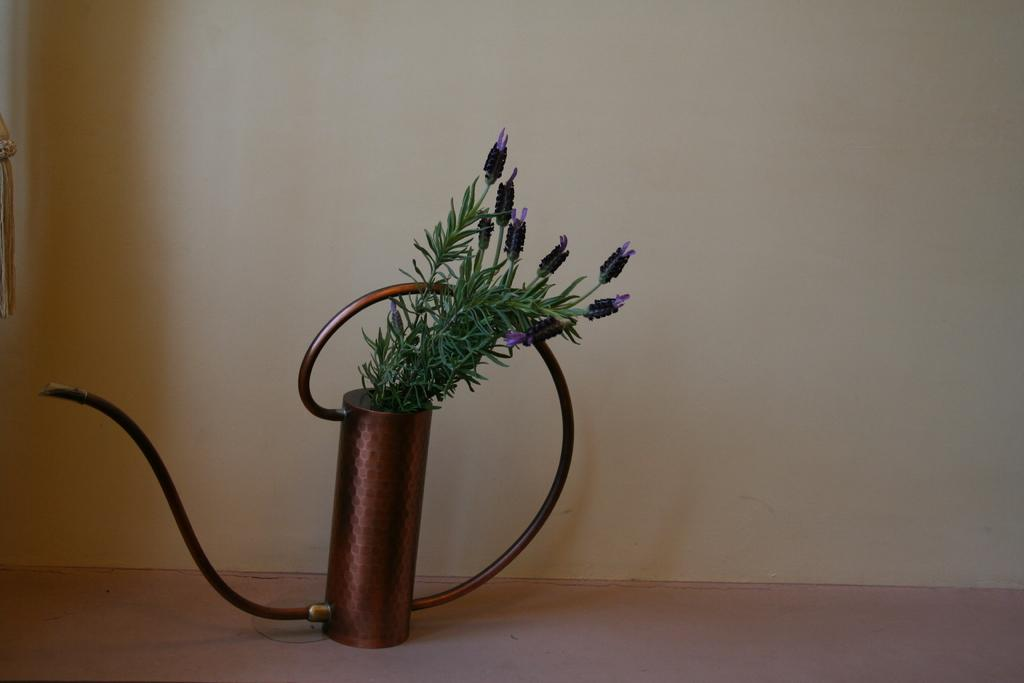What is the main object in the center of the image? There is an object in the center of the image. What type of vegetation can be seen in the image? There are plants in the image. What other object can be seen in the image? There is a pipe in the image. What part of the room is visible at the bottom of the image? The floor is visible at the bottom of the image. What can be seen in the background of the image? There is a wall in the background of the image. How many pizzas are being prepared on the workbench in the image? There is no workbench or pizzas present in the image. 